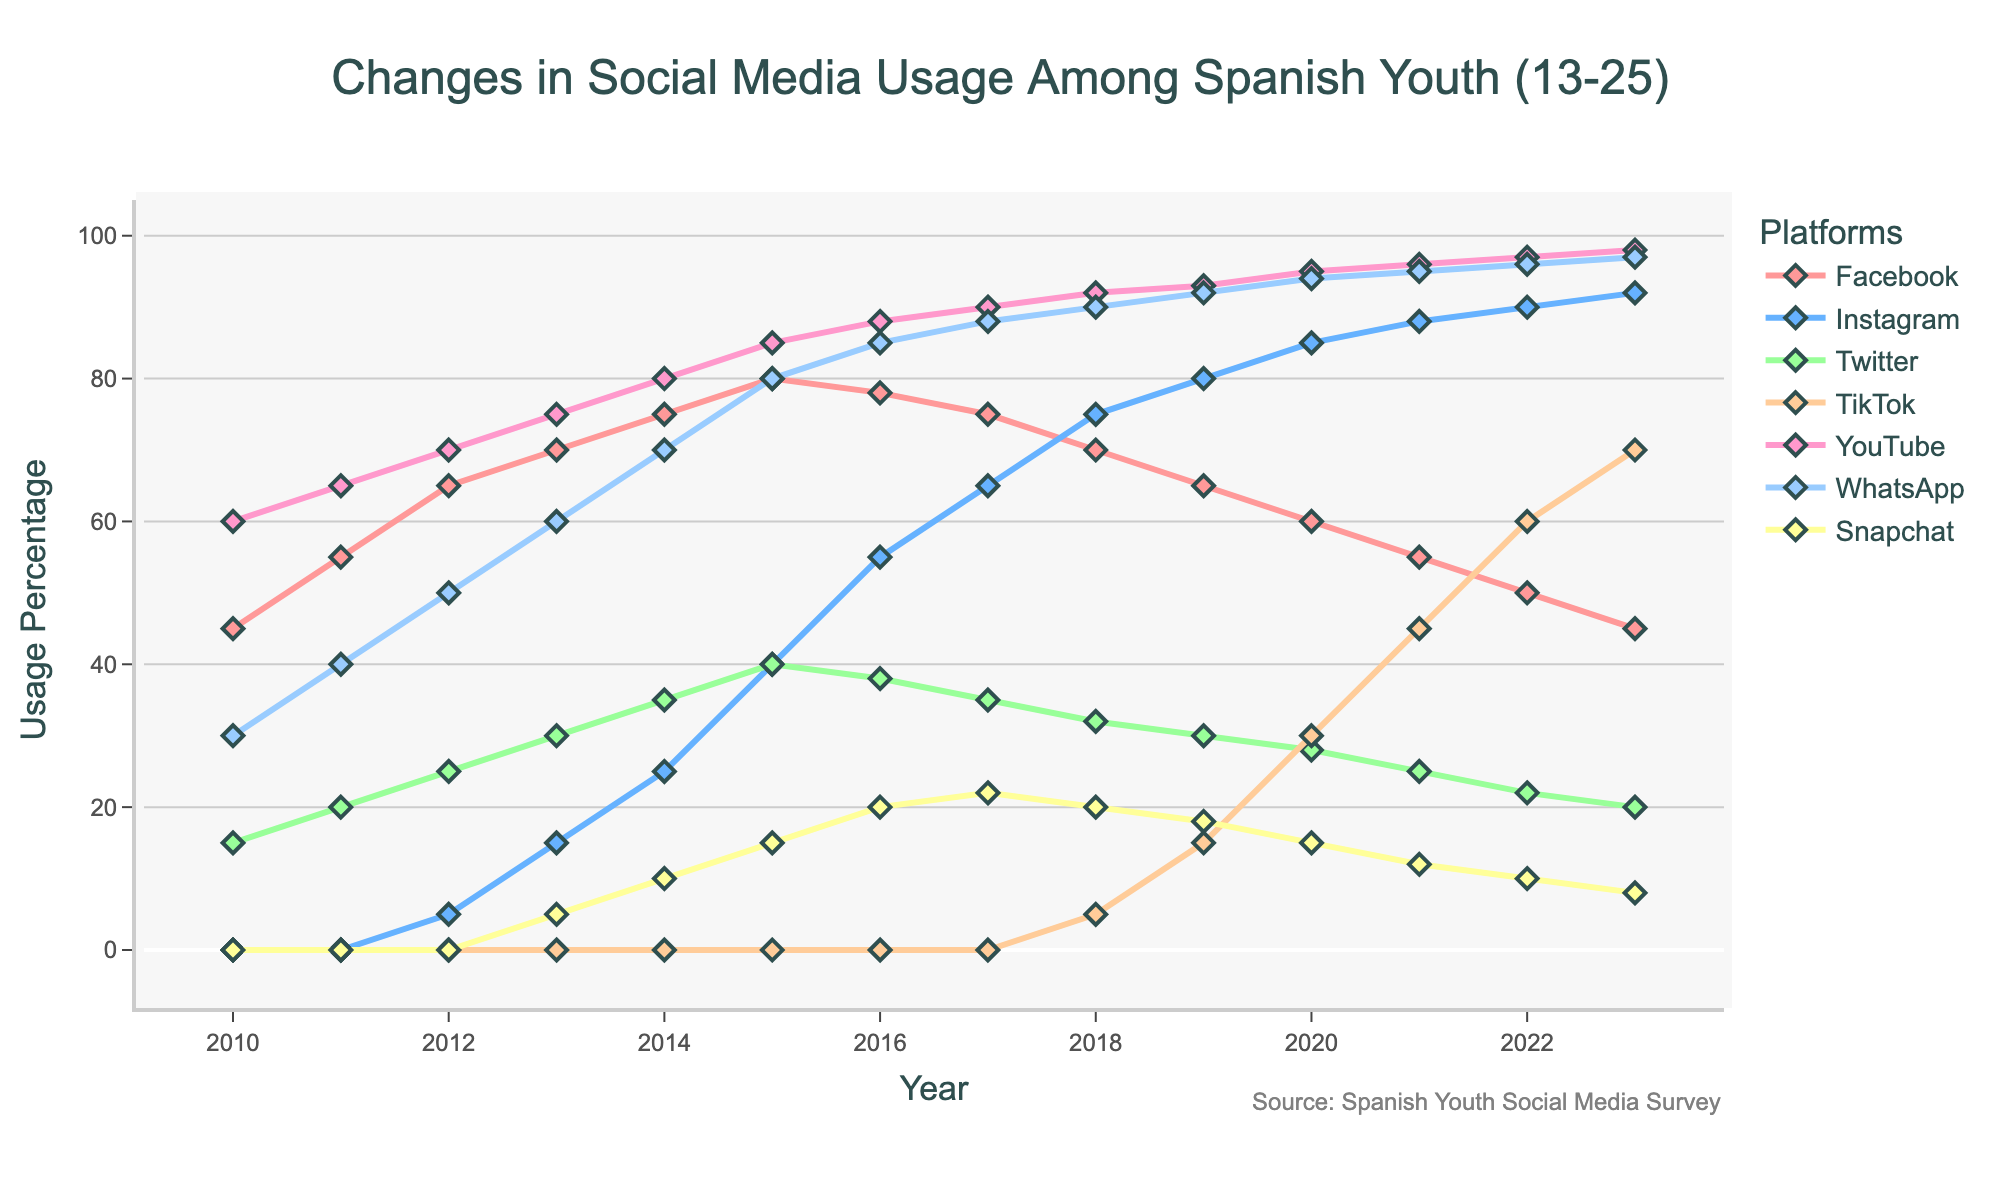What year did Instagram surpass Facebook in usage among Spanish youth? To find this out, we compare the lines representing Instagram and Facebook. Instagram surpasses Facebook between 2020 and 2021. Checking the exact point, Instagram has more usage than Facebook starting in 2021.
Answer: 2021 Between 2010 and 2023, which year had the highest usage of YouTube among Spanish youth? By examining the YouTube line on the chart, we observe the peak values. The highest usage occurs in 2023.
Answer: 2023 What was the approximate difference in TikTok usage between 2018 and 2019? In 2018, TikTok usage was around 5%, and in 2019, it was around 15%. Subtracting the values gives 15 - 5 = 10.
Answer: 10% Which social media platform had the sharpest increase in usage from 2013 to 2015? Comparing the slopes of all lines between 2013 and 2015, Instagram shows the steepest incline, rising from 15% to 40%.
Answer: Instagram By how much did WhatsApp usage change from 2010 to 2023? In 2010, WhatsApp usage was 30%, and in 2023 it reached 97%. The change is 97 - 30 = 67.
Answer: 67% How many platforms showed a decline in usage from 2022 to 2023? From the chart, we see that Facebook, Twitter, and Snapchat lines all decline from 2022 to 2023.
Answer: 3 platforms Which platform had the most consistent growth from 2015 to 2023? By analyzing the trends, TikTok shows continuous and significant growth without any decline or plateau from its start in 2018 to 2023.
Answer: TikTok When did Snapchat show the peak usage, and what was it? The peak for Snapchat can be observed where its line reaches the highest point, which is in 2017 at around 22%.
Answer: 2017, 22% 